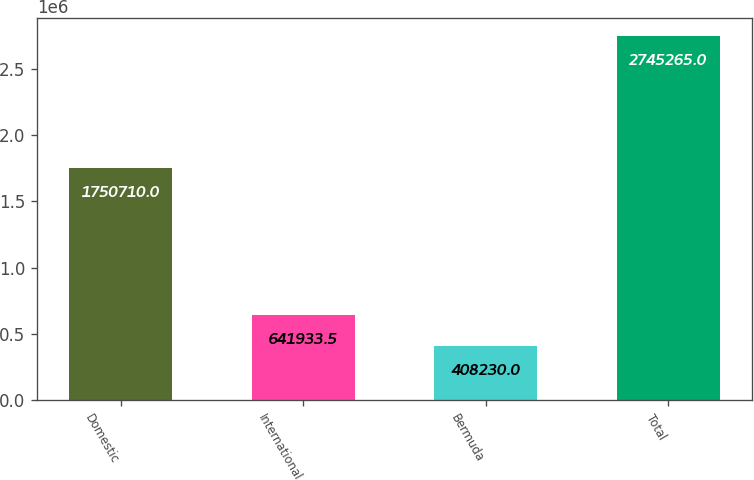<chart> <loc_0><loc_0><loc_500><loc_500><bar_chart><fcel>Domestic<fcel>International<fcel>Bermuda<fcel>Total<nl><fcel>1.75071e+06<fcel>641934<fcel>408230<fcel>2.74526e+06<nl></chart> 